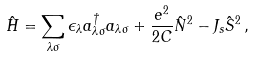Convert formula to latex. <formula><loc_0><loc_0><loc_500><loc_500>\hat { H } = \sum _ { \lambda \sigma } \epsilon _ { \lambda } a ^ { \dagger } _ { \lambda \sigma } a _ { \lambda \sigma } + \frac { e ^ { 2 } } { 2 C } \hat { N } ^ { 2 } - J _ { s } { \hat { S } } ^ { 2 } \, ,</formula> 